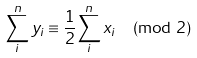Convert formula to latex. <formula><loc_0><loc_0><loc_500><loc_500>\sum _ { i } ^ { n } y _ { i } \equiv { \frac { 1 } { 2 } } { \sum _ { i } ^ { n } x _ { i } } \pmod { 2 } \,</formula> 